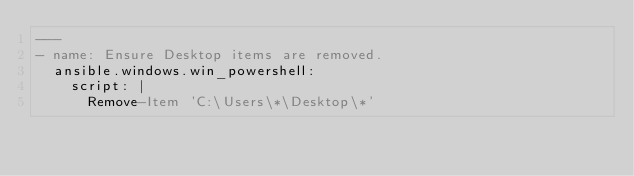<code> <loc_0><loc_0><loc_500><loc_500><_YAML_>---
- name: Ensure Desktop items are removed.
  ansible.windows.win_powershell:
    script: |
      Remove-Item 'C:\Users\*\Desktop\*'
</code> 